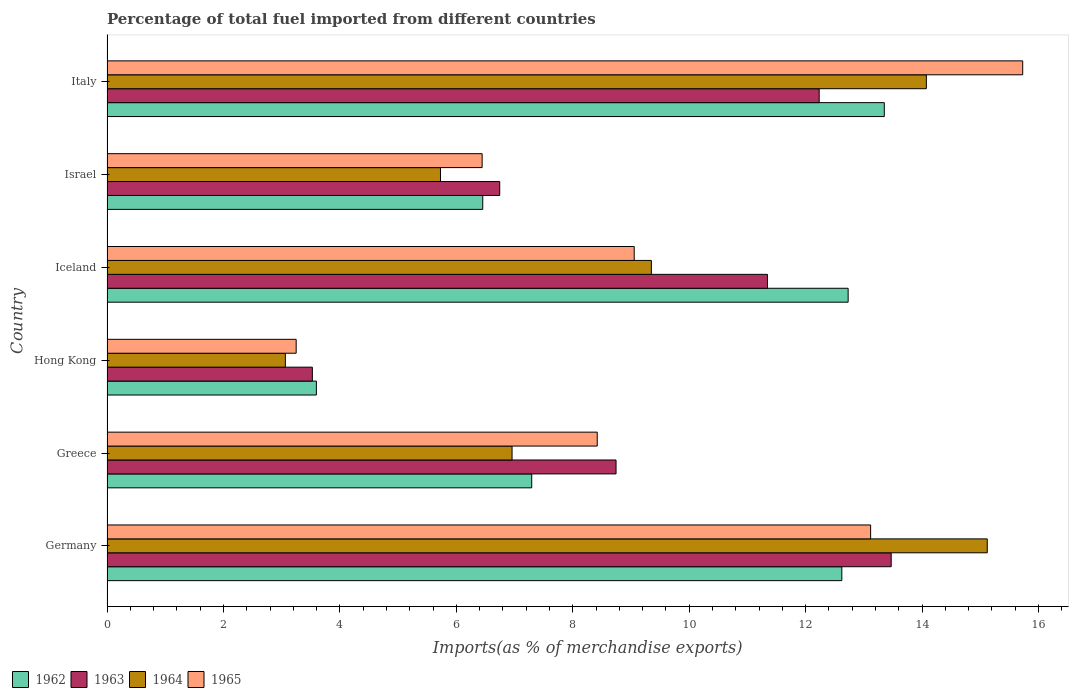How many groups of bars are there?
Make the answer very short. 6. Are the number of bars per tick equal to the number of legend labels?
Offer a terse response. Yes. Are the number of bars on each tick of the Y-axis equal?
Provide a succinct answer. Yes. What is the label of the 5th group of bars from the top?
Your answer should be very brief. Greece. In how many cases, is the number of bars for a given country not equal to the number of legend labels?
Your answer should be very brief. 0. What is the percentage of imports to different countries in 1965 in Iceland?
Your answer should be compact. 9.06. Across all countries, what is the maximum percentage of imports to different countries in 1964?
Your answer should be very brief. 15.12. Across all countries, what is the minimum percentage of imports to different countries in 1963?
Offer a terse response. 3.53. In which country was the percentage of imports to different countries in 1962 minimum?
Keep it short and to the point. Hong Kong. What is the total percentage of imports to different countries in 1962 in the graph?
Keep it short and to the point. 56.05. What is the difference between the percentage of imports to different countries in 1965 in Hong Kong and that in Israel?
Your response must be concise. -3.19. What is the difference between the percentage of imports to different countries in 1963 in Iceland and the percentage of imports to different countries in 1962 in Israel?
Keep it short and to the point. 4.89. What is the average percentage of imports to different countries in 1962 per country?
Offer a very short reply. 9.34. What is the difference between the percentage of imports to different countries in 1964 and percentage of imports to different countries in 1963 in Israel?
Provide a short and direct response. -1.02. In how many countries, is the percentage of imports to different countries in 1963 greater than 16 %?
Provide a short and direct response. 0. What is the ratio of the percentage of imports to different countries in 1964 in Germany to that in Israel?
Make the answer very short. 2.64. What is the difference between the highest and the second highest percentage of imports to different countries in 1962?
Provide a short and direct response. 0.62. What is the difference between the highest and the lowest percentage of imports to different countries in 1963?
Offer a very short reply. 9.94. In how many countries, is the percentage of imports to different countries in 1962 greater than the average percentage of imports to different countries in 1962 taken over all countries?
Ensure brevity in your answer.  3. Is the sum of the percentage of imports to different countries in 1965 in Iceland and Italy greater than the maximum percentage of imports to different countries in 1962 across all countries?
Offer a terse response. Yes. What does the 2nd bar from the top in Greece represents?
Your response must be concise. 1964. What does the 1st bar from the bottom in Israel represents?
Provide a succinct answer. 1962. Is it the case that in every country, the sum of the percentage of imports to different countries in 1963 and percentage of imports to different countries in 1962 is greater than the percentage of imports to different countries in 1965?
Keep it short and to the point. Yes. Are all the bars in the graph horizontal?
Your answer should be very brief. Yes. How many countries are there in the graph?
Provide a short and direct response. 6. Are the values on the major ticks of X-axis written in scientific E-notation?
Your answer should be very brief. No. Does the graph contain any zero values?
Offer a terse response. No. Does the graph contain grids?
Your answer should be compact. No. How are the legend labels stacked?
Offer a terse response. Horizontal. What is the title of the graph?
Your answer should be compact. Percentage of total fuel imported from different countries. Does "2011" appear as one of the legend labels in the graph?
Offer a terse response. No. What is the label or title of the X-axis?
Offer a very short reply. Imports(as % of merchandise exports). What is the label or title of the Y-axis?
Provide a short and direct response. Country. What is the Imports(as % of merchandise exports) in 1962 in Germany?
Provide a short and direct response. 12.62. What is the Imports(as % of merchandise exports) in 1963 in Germany?
Offer a terse response. 13.47. What is the Imports(as % of merchandise exports) of 1964 in Germany?
Make the answer very short. 15.12. What is the Imports(as % of merchandise exports) of 1965 in Germany?
Provide a succinct answer. 13.12. What is the Imports(as % of merchandise exports) of 1962 in Greece?
Offer a terse response. 7.3. What is the Imports(as % of merchandise exports) of 1963 in Greece?
Your answer should be compact. 8.74. What is the Imports(as % of merchandise exports) of 1964 in Greece?
Keep it short and to the point. 6.96. What is the Imports(as % of merchandise exports) of 1965 in Greece?
Your answer should be compact. 8.42. What is the Imports(as % of merchandise exports) of 1962 in Hong Kong?
Offer a terse response. 3.6. What is the Imports(as % of merchandise exports) of 1963 in Hong Kong?
Provide a short and direct response. 3.53. What is the Imports(as % of merchandise exports) of 1964 in Hong Kong?
Offer a very short reply. 3.06. What is the Imports(as % of merchandise exports) of 1965 in Hong Kong?
Provide a short and direct response. 3.25. What is the Imports(as % of merchandise exports) of 1962 in Iceland?
Provide a short and direct response. 12.73. What is the Imports(as % of merchandise exports) of 1963 in Iceland?
Your answer should be very brief. 11.35. What is the Imports(as % of merchandise exports) of 1964 in Iceland?
Offer a very short reply. 9.35. What is the Imports(as % of merchandise exports) of 1965 in Iceland?
Provide a short and direct response. 9.06. What is the Imports(as % of merchandise exports) in 1962 in Israel?
Provide a short and direct response. 6.45. What is the Imports(as % of merchandise exports) in 1963 in Israel?
Your answer should be very brief. 6.75. What is the Imports(as % of merchandise exports) of 1964 in Israel?
Your answer should be very brief. 5.73. What is the Imports(as % of merchandise exports) in 1965 in Israel?
Offer a very short reply. 6.44. What is the Imports(as % of merchandise exports) in 1962 in Italy?
Give a very brief answer. 13.35. What is the Imports(as % of merchandise exports) of 1963 in Italy?
Your answer should be compact. 12.23. What is the Imports(as % of merchandise exports) of 1964 in Italy?
Keep it short and to the point. 14.07. What is the Imports(as % of merchandise exports) in 1965 in Italy?
Offer a terse response. 15.73. Across all countries, what is the maximum Imports(as % of merchandise exports) in 1962?
Your response must be concise. 13.35. Across all countries, what is the maximum Imports(as % of merchandise exports) of 1963?
Ensure brevity in your answer.  13.47. Across all countries, what is the maximum Imports(as % of merchandise exports) in 1964?
Ensure brevity in your answer.  15.12. Across all countries, what is the maximum Imports(as % of merchandise exports) of 1965?
Your answer should be compact. 15.73. Across all countries, what is the minimum Imports(as % of merchandise exports) in 1962?
Ensure brevity in your answer.  3.6. Across all countries, what is the minimum Imports(as % of merchandise exports) of 1963?
Ensure brevity in your answer.  3.53. Across all countries, what is the minimum Imports(as % of merchandise exports) in 1964?
Keep it short and to the point. 3.06. Across all countries, what is the minimum Imports(as % of merchandise exports) in 1965?
Ensure brevity in your answer.  3.25. What is the total Imports(as % of merchandise exports) in 1962 in the graph?
Offer a very short reply. 56.05. What is the total Imports(as % of merchandise exports) in 1963 in the graph?
Give a very brief answer. 56.07. What is the total Imports(as % of merchandise exports) in 1964 in the graph?
Provide a short and direct response. 54.3. What is the total Imports(as % of merchandise exports) of 1965 in the graph?
Ensure brevity in your answer.  56.02. What is the difference between the Imports(as % of merchandise exports) of 1962 in Germany and that in Greece?
Provide a succinct answer. 5.33. What is the difference between the Imports(as % of merchandise exports) in 1963 in Germany and that in Greece?
Offer a very short reply. 4.73. What is the difference between the Imports(as % of merchandise exports) of 1964 in Germany and that in Greece?
Your response must be concise. 8.16. What is the difference between the Imports(as % of merchandise exports) in 1965 in Germany and that in Greece?
Keep it short and to the point. 4.7. What is the difference between the Imports(as % of merchandise exports) of 1962 in Germany and that in Hong Kong?
Offer a terse response. 9.03. What is the difference between the Imports(as % of merchandise exports) of 1963 in Germany and that in Hong Kong?
Provide a succinct answer. 9.94. What is the difference between the Imports(as % of merchandise exports) of 1964 in Germany and that in Hong Kong?
Offer a terse response. 12.06. What is the difference between the Imports(as % of merchandise exports) of 1965 in Germany and that in Hong Kong?
Provide a succinct answer. 9.87. What is the difference between the Imports(as % of merchandise exports) in 1962 in Germany and that in Iceland?
Keep it short and to the point. -0.11. What is the difference between the Imports(as % of merchandise exports) in 1963 in Germany and that in Iceland?
Give a very brief answer. 2.13. What is the difference between the Imports(as % of merchandise exports) of 1964 in Germany and that in Iceland?
Keep it short and to the point. 5.77. What is the difference between the Imports(as % of merchandise exports) of 1965 in Germany and that in Iceland?
Make the answer very short. 4.06. What is the difference between the Imports(as % of merchandise exports) in 1962 in Germany and that in Israel?
Your response must be concise. 6.17. What is the difference between the Imports(as % of merchandise exports) in 1963 in Germany and that in Israel?
Offer a very short reply. 6.72. What is the difference between the Imports(as % of merchandise exports) in 1964 in Germany and that in Israel?
Provide a short and direct response. 9.39. What is the difference between the Imports(as % of merchandise exports) in 1965 in Germany and that in Israel?
Your response must be concise. 6.67. What is the difference between the Imports(as % of merchandise exports) in 1962 in Germany and that in Italy?
Make the answer very short. -0.73. What is the difference between the Imports(as % of merchandise exports) of 1963 in Germany and that in Italy?
Ensure brevity in your answer.  1.24. What is the difference between the Imports(as % of merchandise exports) of 1964 in Germany and that in Italy?
Your answer should be very brief. 1.05. What is the difference between the Imports(as % of merchandise exports) of 1965 in Germany and that in Italy?
Ensure brevity in your answer.  -2.61. What is the difference between the Imports(as % of merchandise exports) in 1962 in Greece and that in Hong Kong?
Provide a succinct answer. 3.7. What is the difference between the Imports(as % of merchandise exports) of 1963 in Greece and that in Hong Kong?
Your answer should be compact. 5.22. What is the difference between the Imports(as % of merchandise exports) in 1964 in Greece and that in Hong Kong?
Give a very brief answer. 3.89. What is the difference between the Imports(as % of merchandise exports) in 1965 in Greece and that in Hong Kong?
Give a very brief answer. 5.17. What is the difference between the Imports(as % of merchandise exports) of 1962 in Greece and that in Iceland?
Give a very brief answer. -5.44. What is the difference between the Imports(as % of merchandise exports) of 1963 in Greece and that in Iceland?
Offer a very short reply. -2.6. What is the difference between the Imports(as % of merchandise exports) in 1964 in Greece and that in Iceland?
Your answer should be compact. -2.39. What is the difference between the Imports(as % of merchandise exports) in 1965 in Greece and that in Iceland?
Make the answer very short. -0.64. What is the difference between the Imports(as % of merchandise exports) in 1962 in Greece and that in Israel?
Provide a succinct answer. 0.84. What is the difference between the Imports(as % of merchandise exports) of 1963 in Greece and that in Israel?
Your answer should be very brief. 2. What is the difference between the Imports(as % of merchandise exports) in 1964 in Greece and that in Israel?
Your answer should be very brief. 1.23. What is the difference between the Imports(as % of merchandise exports) of 1965 in Greece and that in Israel?
Your answer should be compact. 1.98. What is the difference between the Imports(as % of merchandise exports) in 1962 in Greece and that in Italy?
Ensure brevity in your answer.  -6.06. What is the difference between the Imports(as % of merchandise exports) of 1963 in Greece and that in Italy?
Ensure brevity in your answer.  -3.49. What is the difference between the Imports(as % of merchandise exports) of 1964 in Greece and that in Italy?
Offer a terse response. -7.12. What is the difference between the Imports(as % of merchandise exports) of 1965 in Greece and that in Italy?
Your answer should be compact. -7.31. What is the difference between the Imports(as % of merchandise exports) in 1962 in Hong Kong and that in Iceland?
Give a very brief answer. -9.13. What is the difference between the Imports(as % of merchandise exports) of 1963 in Hong Kong and that in Iceland?
Ensure brevity in your answer.  -7.82. What is the difference between the Imports(as % of merchandise exports) of 1964 in Hong Kong and that in Iceland?
Your answer should be compact. -6.29. What is the difference between the Imports(as % of merchandise exports) in 1965 in Hong Kong and that in Iceland?
Your answer should be compact. -5.81. What is the difference between the Imports(as % of merchandise exports) of 1962 in Hong Kong and that in Israel?
Offer a very short reply. -2.86. What is the difference between the Imports(as % of merchandise exports) of 1963 in Hong Kong and that in Israel?
Make the answer very short. -3.22. What is the difference between the Imports(as % of merchandise exports) in 1964 in Hong Kong and that in Israel?
Your answer should be very brief. -2.66. What is the difference between the Imports(as % of merchandise exports) in 1965 in Hong Kong and that in Israel?
Offer a terse response. -3.19. What is the difference between the Imports(as % of merchandise exports) of 1962 in Hong Kong and that in Italy?
Your response must be concise. -9.76. What is the difference between the Imports(as % of merchandise exports) of 1963 in Hong Kong and that in Italy?
Your answer should be very brief. -8.71. What is the difference between the Imports(as % of merchandise exports) in 1964 in Hong Kong and that in Italy?
Keep it short and to the point. -11.01. What is the difference between the Imports(as % of merchandise exports) of 1965 in Hong Kong and that in Italy?
Keep it short and to the point. -12.48. What is the difference between the Imports(as % of merchandise exports) of 1962 in Iceland and that in Israel?
Offer a terse response. 6.28. What is the difference between the Imports(as % of merchandise exports) of 1963 in Iceland and that in Israel?
Your answer should be compact. 4.6. What is the difference between the Imports(as % of merchandise exports) of 1964 in Iceland and that in Israel?
Your answer should be very brief. 3.62. What is the difference between the Imports(as % of merchandise exports) in 1965 in Iceland and that in Israel?
Your answer should be very brief. 2.61. What is the difference between the Imports(as % of merchandise exports) in 1962 in Iceland and that in Italy?
Keep it short and to the point. -0.62. What is the difference between the Imports(as % of merchandise exports) of 1963 in Iceland and that in Italy?
Make the answer very short. -0.89. What is the difference between the Imports(as % of merchandise exports) in 1964 in Iceland and that in Italy?
Offer a very short reply. -4.72. What is the difference between the Imports(as % of merchandise exports) of 1965 in Iceland and that in Italy?
Provide a short and direct response. -6.67. What is the difference between the Imports(as % of merchandise exports) of 1962 in Israel and that in Italy?
Provide a succinct answer. -6.9. What is the difference between the Imports(as % of merchandise exports) of 1963 in Israel and that in Italy?
Offer a very short reply. -5.49. What is the difference between the Imports(as % of merchandise exports) of 1964 in Israel and that in Italy?
Make the answer very short. -8.35. What is the difference between the Imports(as % of merchandise exports) in 1965 in Israel and that in Italy?
Make the answer very short. -9.29. What is the difference between the Imports(as % of merchandise exports) of 1962 in Germany and the Imports(as % of merchandise exports) of 1963 in Greece?
Your response must be concise. 3.88. What is the difference between the Imports(as % of merchandise exports) of 1962 in Germany and the Imports(as % of merchandise exports) of 1964 in Greece?
Your answer should be very brief. 5.66. What is the difference between the Imports(as % of merchandise exports) of 1962 in Germany and the Imports(as % of merchandise exports) of 1965 in Greece?
Provide a short and direct response. 4.2. What is the difference between the Imports(as % of merchandise exports) in 1963 in Germany and the Imports(as % of merchandise exports) in 1964 in Greece?
Provide a succinct answer. 6.51. What is the difference between the Imports(as % of merchandise exports) in 1963 in Germany and the Imports(as % of merchandise exports) in 1965 in Greece?
Keep it short and to the point. 5.05. What is the difference between the Imports(as % of merchandise exports) in 1964 in Germany and the Imports(as % of merchandise exports) in 1965 in Greece?
Your answer should be very brief. 6.7. What is the difference between the Imports(as % of merchandise exports) of 1962 in Germany and the Imports(as % of merchandise exports) of 1963 in Hong Kong?
Keep it short and to the point. 9.1. What is the difference between the Imports(as % of merchandise exports) of 1962 in Germany and the Imports(as % of merchandise exports) of 1964 in Hong Kong?
Offer a terse response. 9.56. What is the difference between the Imports(as % of merchandise exports) of 1962 in Germany and the Imports(as % of merchandise exports) of 1965 in Hong Kong?
Your answer should be compact. 9.37. What is the difference between the Imports(as % of merchandise exports) in 1963 in Germany and the Imports(as % of merchandise exports) in 1964 in Hong Kong?
Make the answer very short. 10.41. What is the difference between the Imports(as % of merchandise exports) in 1963 in Germany and the Imports(as % of merchandise exports) in 1965 in Hong Kong?
Ensure brevity in your answer.  10.22. What is the difference between the Imports(as % of merchandise exports) of 1964 in Germany and the Imports(as % of merchandise exports) of 1965 in Hong Kong?
Provide a short and direct response. 11.87. What is the difference between the Imports(as % of merchandise exports) in 1962 in Germany and the Imports(as % of merchandise exports) in 1963 in Iceland?
Offer a very short reply. 1.28. What is the difference between the Imports(as % of merchandise exports) of 1962 in Germany and the Imports(as % of merchandise exports) of 1964 in Iceland?
Your response must be concise. 3.27. What is the difference between the Imports(as % of merchandise exports) of 1962 in Germany and the Imports(as % of merchandise exports) of 1965 in Iceland?
Give a very brief answer. 3.57. What is the difference between the Imports(as % of merchandise exports) of 1963 in Germany and the Imports(as % of merchandise exports) of 1964 in Iceland?
Offer a terse response. 4.12. What is the difference between the Imports(as % of merchandise exports) of 1963 in Germany and the Imports(as % of merchandise exports) of 1965 in Iceland?
Offer a very short reply. 4.41. What is the difference between the Imports(as % of merchandise exports) of 1964 in Germany and the Imports(as % of merchandise exports) of 1965 in Iceland?
Ensure brevity in your answer.  6.06. What is the difference between the Imports(as % of merchandise exports) of 1962 in Germany and the Imports(as % of merchandise exports) of 1963 in Israel?
Make the answer very short. 5.88. What is the difference between the Imports(as % of merchandise exports) of 1962 in Germany and the Imports(as % of merchandise exports) of 1964 in Israel?
Ensure brevity in your answer.  6.89. What is the difference between the Imports(as % of merchandise exports) of 1962 in Germany and the Imports(as % of merchandise exports) of 1965 in Israel?
Keep it short and to the point. 6.18. What is the difference between the Imports(as % of merchandise exports) of 1963 in Germany and the Imports(as % of merchandise exports) of 1964 in Israel?
Keep it short and to the point. 7.74. What is the difference between the Imports(as % of merchandise exports) in 1963 in Germany and the Imports(as % of merchandise exports) in 1965 in Israel?
Make the answer very short. 7.03. What is the difference between the Imports(as % of merchandise exports) of 1964 in Germany and the Imports(as % of merchandise exports) of 1965 in Israel?
Offer a very short reply. 8.68. What is the difference between the Imports(as % of merchandise exports) of 1962 in Germany and the Imports(as % of merchandise exports) of 1963 in Italy?
Give a very brief answer. 0.39. What is the difference between the Imports(as % of merchandise exports) in 1962 in Germany and the Imports(as % of merchandise exports) in 1964 in Italy?
Provide a succinct answer. -1.45. What is the difference between the Imports(as % of merchandise exports) of 1962 in Germany and the Imports(as % of merchandise exports) of 1965 in Italy?
Your response must be concise. -3.11. What is the difference between the Imports(as % of merchandise exports) in 1963 in Germany and the Imports(as % of merchandise exports) in 1964 in Italy?
Offer a very short reply. -0.6. What is the difference between the Imports(as % of merchandise exports) in 1963 in Germany and the Imports(as % of merchandise exports) in 1965 in Italy?
Offer a terse response. -2.26. What is the difference between the Imports(as % of merchandise exports) of 1964 in Germany and the Imports(as % of merchandise exports) of 1965 in Italy?
Your answer should be compact. -0.61. What is the difference between the Imports(as % of merchandise exports) in 1962 in Greece and the Imports(as % of merchandise exports) in 1963 in Hong Kong?
Your answer should be compact. 3.77. What is the difference between the Imports(as % of merchandise exports) in 1962 in Greece and the Imports(as % of merchandise exports) in 1964 in Hong Kong?
Your response must be concise. 4.23. What is the difference between the Imports(as % of merchandise exports) in 1962 in Greece and the Imports(as % of merchandise exports) in 1965 in Hong Kong?
Provide a succinct answer. 4.05. What is the difference between the Imports(as % of merchandise exports) in 1963 in Greece and the Imports(as % of merchandise exports) in 1964 in Hong Kong?
Your response must be concise. 5.68. What is the difference between the Imports(as % of merchandise exports) of 1963 in Greece and the Imports(as % of merchandise exports) of 1965 in Hong Kong?
Provide a short and direct response. 5.49. What is the difference between the Imports(as % of merchandise exports) in 1964 in Greece and the Imports(as % of merchandise exports) in 1965 in Hong Kong?
Your response must be concise. 3.71. What is the difference between the Imports(as % of merchandise exports) in 1962 in Greece and the Imports(as % of merchandise exports) in 1963 in Iceland?
Offer a very short reply. -4.05. What is the difference between the Imports(as % of merchandise exports) in 1962 in Greece and the Imports(as % of merchandise exports) in 1964 in Iceland?
Offer a very short reply. -2.06. What is the difference between the Imports(as % of merchandise exports) of 1962 in Greece and the Imports(as % of merchandise exports) of 1965 in Iceland?
Provide a succinct answer. -1.76. What is the difference between the Imports(as % of merchandise exports) of 1963 in Greece and the Imports(as % of merchandise exports) of 1964 in Iceland?
Offer a very short reply. -0.61. What is the difference between the Imports(as % of merchandise exports) in 1963 in Greece and the Imports(as % of merchandise exports) in 1965 in Iceland?
Offer a very short reply. -0.31. What is the difference between the Imports(as % of merchandise exports) in 1964 in Greece and the Imports(as % of merchandise exports) in 1965 in Iceland?
Offer a very short reply. -2.1. What is the difference between the Imports(as % of merchandise exports) in 1962 in Greece and the Imports(as % of merchandise exports) in 1963 in Israel?
Your answer should be compact. 0.55. What is the difference between the Imports(as % of merchandise exports) of 1962 in Greece and the Imports(as % of merchandise exports) of 1964 in Israel?
Ensure brevity in your answer.  1.57. What is the difference between the Imports(as % of merchandise exports) of 1962 in Greece and the Imports(as % of merchandise exports) of 1965 in Israel?
Provide a short and direct response. 0.85. What is the difference between the Imports(as % of merchandise exports) of 1963 in Greece and the Imports(as % of merchandise exports) of 1964 in Israel?
Your response must be concise. 3.02. What is the difference between the Imports(as % of merchandise exports) of 1963 in Greece and the Imports(as % of merchandise exports) of 1965 in Israel?
Keep it short and to the point. 2.3. What is the difference between the Imports(as % of merchandise exports) in 1964 in Greece and the Imports(as % of merchandise exports) in 1965 in Israel?
Keep it short and to the point. 0.51. What is the difference between the Imports(as % of merchandise exports) in 1962 in Greece and the Imports(as % of merchandise exports) in 1963 in Italy?
Your response must be concise. -4.94. What is the difference between the Imports(as % of merchandise exports) of 1962 in Greece and the Imports(as % of merchandise exports) of 1964 in Italy?
Offer a very short reply. -6.78. What is the difference between the Imports(as % of merchandise exports) in 1962 in Greece and the Imports(as % of merchandise exports) in 1965 in Italy?
Your answer should be very brief. -8.43. What is the difference between the Imports(as % of merchandise exports) in 1963 in Greece and the Imports(as % of merchandise exports) in 1964 in Italy?
Provide a short and direct response. -5.33. What is the difference between the Imports(as % of merchandise exports) in 1963 in Greece and the Imports(as % of merchandise exports) in 1965 in Italy?
Give a very brief answer. -6.99. What is the difference between the Imports(as % of merchandise exports) in 1964 in Greece and the Imports(as % of merchandise exports) in 1965 in Italy?
Keep it short and to the point. -8.77. What is the difference between the Imports(as % of merchandise exports) of 1962 in Hong Kong and the Imports(as % of merchandise exports) of 1963 in Iceland?
Keep it short and to the point. -7.75. What is the difference between the Imports(as % of merchandise exports) of 1962 in Hong Kong and the Imports(as % of merchandise exports) of 1964 in Iceland?
Your response must be concise. -5.75. What is the difference between the Imports(as % of merchandise exports) in 1962 in Hong Kong and the Imports(as % of merchandise exports) in 1965 in Iceland?
Keep it short and to the point. -5.46. What is the difference between the Imports(as % of merchandise exports) of 1963 in Hong Kong and the Imports(as % of merchandise exports) of 1964 in Iceland?
Provide a short and direct response. -5.82. What is the difference between the Imports(as % of merchandise exports) in 1963 in Hong Kong and the Imports(as % of merchandise exports) in 1965 in Iceland?
Ensure brevity in your answer.  -5.53. What is the difference between the Imports(as % of merchandise exports) in 1964 in Hong Kong and the Imports(as % of merchandise exports) in 1965 in Iceland?
Ensure brevity in your answer.  -5.99. What is the difference between the Imports(as % of merchandise exports) in 1962 in Hong Kong and the Imports(as % of merchandise exports) in 1963 in Israel?
Offer a very short reply. -3.15. What is the difference between the Imports(as % of merchandise exports) in 1962 in Hong Kong and the Imports(as % of merchandise exports) in 1964 in Israel?
Make the answer very short. -2.13. What is the difference between the Imports(as % of merchandise exports) in 1962 in Hong Kong and the Imports(as % of merchandise exports) in 1965 in Israel?
Offer a very short reply. -2.85. What is the difference between the Imports(as % of merchandise exports) in 1963 in Hong Kong and the Imports(as % of merchandise exports) in 1964 in Israel?
Provide a succinct answer. -2.2. What is the difference between the Imports(as % of merchandise exports) of 1963 in Hong Kong and the Imports(as % of merchandise exports) of 1965 in Israel?
Your answer should be compact. -2.92. What is the difference between the Imports(as % of merchandise exports) in 1964 in Hong Kong and the Imports(as % of merchandise exports) in 1965 in Israel?
Your answer should be compact. -3.38. What is the difference between the Imports(as % of merchandise exports) of 1962 in Hong Kong and the Imports(as % of merchandise exports) of 1963 in Italy?
Offer a very short reply. -8.64. What is the difference between the Imports(as % of merchandise exports) in 1962 in Hong Kong and the Imports(as % of merchandise exports) in 1964 in Italy?
Provide a succinct answer. -10.48. What is the difference between the Imports(as % of merchandise exports) in 1962 in Hong Kong and the Imports(as % of merchandise exports) in 1965 in Italy?
Provide a short and direct response. -12.13. What is the difference between the Imports(as % of merchandise exports) of 1963 in Hong Kong and the Imports(as % of merchandise exports) of 1964 in Italy?
Give a very brief answer. -10.55. What is the difference between the Imports(as % of merchandise exports) of 1963 in Hong Kong and the Imports(as % of merchandise exports) of 1965 in Italy?
Make the answer very short. -12.2. What is the difference between the Imports(as % of merchandise exports) of 1964 in Hong Kong and the Imports(as % of merchandise exports) of 1965 in Italy?
Make the answer very short. -12.67. What is the difference between the Imports(as % of merchandise exports) of 1962 in Iceland and the Imports(as % of merchandise exports) of 1963 in Israel?
Give a very brief answer. 5.99. What is the difference between the Imports(as % of merchandise exports) in 1962 in Iceland and the Imports(as % of merchandise exports) in 1964 in Israel?
Your answer should be very brief. 7. What is the difference between the Imports(as % of merchandise exports) of 1962 in Iceland and the Imports(as % of merchandise exports) of 1965 in Israel?
Offer a terse response. 6.29. What is the difference between the Imports(as % of merchandise exports) of 1963 in Iceland and the Imports(as % of merchandise exports) of 1964 in Israel?
Your answer should be compact. 5.62. What is the difference between the Imports(as % of merchandise exports) of 1963 in Iceland and the Imports(as % of merchandise exports) of 1965 in Israel?
Offer a very short reply. 4.9. What is the difference between the Imports(as % of merchandise exports) of 1964 in Iceland and the Imports(as % of merchandise exports) of 1965 in Israel?
Offer a very short reply. 2.91. What is the difference between the Imports(as % of merchandise exports) in 1962 in Iceland and the Imports(as % of merchandise exports) in 1963 in Italy?
Your response must be concise. 0.5. What is the difference between the Imports(as % of merchandise exports) in 1962 in Iceland and the Imports(as % of merchandise exports) in 1964 in Italy?
Your answer should be very brief. -1.34. What is the difference between the Imports(as % of merchandise exports) of 1962 in Iceland and the Imports(as % of merchandise exports) of 1965 in Italy?
Your response must be concise. -3. What is the difference between the Imports(as % of merchandise exports) in 1963 in Iceland and the Imports(as % of merchandise exports) in 1964 in Italy?
Your answer should be very brief. -2.73. What is the difference between the Imports(as % of merchandise exports) of 1963 in Iceland and the Imports(as % of merchandise exports) of 1965 in Italy?
Give a very brief answer. -4.38. What is the difference between the Imports(as % of merchandise exports) of 1964 in Iceland and the Imports(as % of merchandise exports) of 1965 in Italy?
Give a very brief answer. -6.38. What is the difference between the Imports(as % of merchandise exports) of 1962 in Israel and the Imports(as % of merchandise exports) of 1963 in Italy?
Ensure brevity in your answer.  -5.78. What is the difference between the Imports(as % of merchandise exports) of 1962 in Israel and the Imports(as % of merchandise exports) of 1964 in Italy?
Ensure brevity in your answer.  -7.62. What is the difference between the Imports(as % of merchandise exports) of 1962 in Israel and the Imports(as % of merchandise exports) of 1965 in Italy?
Offer a terse response. -9.28. What is the difference between the Imports(as % of merchandise exports) of 1963 in Israel and the Imports(as % of merchandise exports) of 1964 in Italy?
Ensure brevity in your answer.  -7.33. What is the difference between the Imports(as % of merchandise exports) of 1963 in Israel and the Imports(as % of merchandise exports) of 1965 in Italy?
Your answer should be very brief. -8.98. What is the difference between the Imports(as % of merchandise exports) in 1964 in Israel and the Imports(as % of merchandise exports) in 1965 in Italy?
Provide a succinct answer. -10. What is the average Imports(as % of merchandise exports) of 1962 per country?
Your response must be concise. 9.34. What is the average Imports(as % of merchandise exports) in 1963 per country?
Provide a succinct answer. 9.34. What is the average Imports(as % of merchandise exports) in 1964 per country?
Ensure brevity in your answer.  9.05. What is the average Imports(as % of merchandise exports) in 1965 per country?
Your answer should be very brief. 9.34. What is the difference between the Imports(as % of merchandise exports) in 1962 and Imports(as % of merchandise exports) in 1963 in Germany?
Provide a short and direct response. -0.85. What is the difference between the Imports(as % of merchandise exports) of 1962 and Imports(as % of merchandise exports) of 1964 in Germany?
Offer a terse response. -2.5. What is the difference between the Imports(as % of merchandise exports) of 1962 and Imports(as % of merchandise exports) of 1965 in Germany?
Keep it short and to the point. -0.49. What is the difference between the Imports(as % of merchandise exports) of 1963 and Imports(as % of merchandise exports) of 1964 in Germany?
Provide a succinct answer. -1.65. What is the difference between the Imports(as % of merchandise exports) of 1963 and Imports(as % of merchandise exports) of 1965 in Germany?
Give a very brief answer. 0.35. What is the difference between the Imports(as % of merchandise exports) in 1964 and Imports(as % of merchandise exports) in 1965 in Germany?
Provide a succinct answer. 2. What is the difference between the Imports(as % of merchandise exports) in 1962 and Imports(as % of merchandise exports) in 1963 in Greece?
Provide a succinct answer. -1.45. What is the difference between the Imports(as % of merchandise exports) of 1962 and Imports(as % of merchandise exports) of 1964 in Greece?
Give a very brief answer. 0.34. What is the difference between the Imports(as % of merchandise exports) in 1962 and Imports(as % of merchandise exports) in 1965 in Greece?
Make the answer very short. -1.13. What is the difference between the Imports(as % of merchandise exports) in 1963 and Imports(as % of merchandise exports) in 1964 in Greece?
Keep it short and to the point. 1.79. What is the difference between the Imports(as % of merchandise exports) of 1963 and Imports(as % of merchandise exports) of 1965 in Greece?
Offer a terse response. 0.32. What is the difference between the Imports(as % of merchandise exports) in 1964 and Imports(as % of merchandise exports) in 1965 in Greece?
Your response must be concise. -1.46. What is the difference between the Imports(as % of merchandise exports) of 1962 and Imports(as % of merchandise exports) of 1963 in Hong Kong?
Offer a very short reply. 0.07. What is the difference between the Imports(as % of merchandise exports) in 1962 and Imports(as % of merchandise exports) in 1964 in Hong Kong?
Offer a very short reply. 0.53. What is the difference between the Imports(as % of merchandise exports) of 1962 and Imports(as % of merchandise exports) of 1965 in Hong Kong?
Keep it short and to the point. 0.35. What is the difference between the Imports(as % of merchandise exports) of 1963 and Imports(as % of merchandise exports) of 1964 in Hong Kong?
Provide a short and direct response. 0.46. What is the difference between the Imports(as % of merchandise exports) in 1963 and Imports(as % of merchandise exports) in 1965 in Hong Kong?
Make the answer very short. 0.28. What is the difference between the Imports(as % of merchandise exports) of 1964 and Imports(as % of merchandise exports) of 1965 in Hong Kong?
Provide a succinct answer. -0.19. What is the difference between the Imports(as % of merchandise exports) in 1962 and Imports(as % of merchandise exports) in 1963 in Iceland?
Keep it short and to the point. 1.39. What is the difference between the Imports(as % of merchandise exports) in 1962 and Imports(as % of merchandise exports) in 1964 in Iceland?
Provide a short and direct response. 3.38. What is the difference between the Imports(as % of merchandise exports) in 1962 and Imports(as % of merchandise exports) in 1965 in Iceland?
Your answer should be compact. 3.67. What is the difference between the Imports(as % of merchandise exports) of 1963 and Imports(as % of merchandise exports) of 1964 in Iceland?
Provide a succinct answer. 1.99. What is the difference between the Imports(as % of merchandise exports) of 1963 and Imports(as % of merchandise exports) of 1965 in Iceland?
Offer a very short reply. 2.29. What is the difference between the Imports(as % of merchandise exports) in 1964 and Imports(as % of merchandise exports) in 1965 in Iceland?
Ensure brevity in your answer.  0.29. What is the difference between the Imports(as % of merchandise exports) of 1962 and Imports(as % of merchandise exports) of 1963 in Israel?
Provide a short and direct response. -0.29. What is the difference between the Imports(as % of merchandise exports) in 1962 and Imports(as % of merchandise exports) in 1964 in Israel?
Your response must be concise. 0.73. What is the difference between the Imports(as % of merchandise exports) in 1962 and Imports(as % of merchandise exports) in 1965 in Israel?
Give a very brief answer. 0.01. What is the difference between the Imports(as % of merchandise exports) in 1963 and Imports(as % of merchandise exports) in 1964 in Israel?
Make the answer very short. 1.02. What is the difference between the Imports(as % of merchandise exports) in 1963 and Imports(as % of merchandise exports) in 1965 in Israel?
Your response must be concise. 0.3. What is the difference between the Imports(as % of merchandise exports) of 1964 and Imports(as % of merchandise exports) of 1965 in Israel?
Give a very brief answer. -0.72. What is the difference between the Imports(as % of merchandise exports) in 1962 and Imports(as % of merchandise exports) in 1963 in Italy?
Your answer should be very brief. 1.12. What is the difference between the Imports(as % of merchandise exports) of 1962 and Imports(as % of merchandise exports) of 1964 in Italy?
Ensure brevity in your answer.  -0.72. What is the difference between the Imports(as % of merchandise exports) in 1962 and Imports(as % of merchandise exports) in 1965 in Italy?
Offer a very short reply. -2.38. What is the difference between the Imports(as % of merchandise exports) in 1963 and Imports(as % of merchandise exports) in 1964 in Italy?
Offer a terse response. -1.84. What is the difference between the Imports(as % of merchandise exports) in 1963 and Imports(as % of merchandise exports) in 1965 in Italy?
Make the answer very short. -3.5. What is the difference between the Imports(as % of merchandise exports) in 1964 and Imports(as % of merchandise exports) in 1965 in Italy?
Provide a short and direct response. -1.65. What is the ratio of the Imports(as % of merchandise exports) of 1962 in Germany to that in Greece?
Offer a very short reply. 1.73. What is the ratio of the Imports(as % of merchandise exports) of 1963 in Germany to that in Greece?
Your answer should be compact. 1.54. What is the ratio of the Imports(as % of merchandise exports) in 1964 in Germany to that in Greece?
Keep it short and to the point. 2.17. What is the ratio of the Imports(as % of merchandise exports) of 1965 in Germany to that in Greece?
Keep it short and to the point. 1.56. What is the ratio of the Imports(as % of merchandise exports) of 1962 in Germany to that in Hong Kong?
Your answer should be very brief. 3.51. What is the ratio of the Imports(as % of merchandise exports) of 1963 in Germany to that in Hong Kong?
Offer a terse response. 3.82. What is the ratio of the Imports(as % of merchandise exports) in 1964 in Germany to that in Hong Kong?
Offer a very short reply. 4.94. What is the ratio of the Imports(as % of merchandise exports) of 1965 in Germany to that in Hong Kong?
Offer a terse response. 4.04. What is the ratio of the Imports(as % of merchandise exports) in 1963 in Germany to that in Iceland?
Give a very brief answer. 1.19. What is the ratio of the Imports(as % of merchandise exports) of 1964 in Germany to that in Iceland?
Give a very brief answer. 1.62. What is the ratio of the Imports(as % of merchandise exports) in 1965 in Germany to that in Iceland?
Your answer should be compact. 1.45. What is the ratio of the Imports(as % of merchandise exports) in 1962 in Germany to that in Israel?
Provide a short and direct response. 1.96. What is the ratio of the Imports(as % of merchandise exports) in 1963 in Germany to that in Israel?
Give a very brief answer. 2. What is the ratio of the Imports(as % of merchandise exports) of 1964 in Germany to that in Israel?
Provide a short and direct response. 2.64. What is the ratio of the Imports(as % of merchandise exports) in 1965 in Germany to that in Israel?
Your answer should be compact. 2.04. What is the ratio of the Imports(as % of merchandise exports) in 1962 in Germany to that in Italy?
Give a very brief answer. 0.95. What is the ratio of the Imports(as % of merchandise exports) in 1963 in Germany to that in Italy?
Keep it short and to the point. 1.1. What is the ratio of the Imports(as % of merchandise exports) of 1964 in Germany to that in Italy?
Offer a very short reply. 1.07. What is the ratio of the Imports(as % of merchandise exports) of 1965 in Germany to that in Italy?
Provide a succinct answer. 0.83. What is the ratio of the Imports(as % of merchandise exports) of 1962 in Greece to that in Hong Kong?
Your response must be concise. 2.03. What is the ratio of the Imports(as % of merchandise exports) of 1963 in Greece to that in Hong Kong?
Make the answer very short. 2.48. What is the ratio of the Imports(as % of merchandise exports) in 1964 in Greece to that in Hong Kong?
Provide a succinct answer. 2.27. What is the ratio of the Imports(as % of merchandise exports) in 1965 in Greece to that in Hong Kong?
Offer a very short reply. 2.59. What is the ratio of the Imports(as % of merchandise exports) of 1962 in Greece to that in Iceland?
Provide a short and direct response. 0.57. What is the ratio of the Imports(as % of merchandise exports) in 1963 in Greece to that in Iceland?
Keep it short and to the point. 0.77. What is the ratio of the Imports(as % of merchandise exports) in 1964 in Greece to that in Iceland?
Provide a succinct answer. 0.74. What is the ratio of the Imports(as % of merchandise exports) in 1965 in Greece to that in Iceland?
Offer a very short reply. 0.93. What is the ratio of the Imports(as % of merchandise exports) in 1962 in Greece to that in Israel?
Offer a terse response. 1.13. What is the ratio of the Imports(as % of merchandise exports) of 1963 in Greece to that in Israel?
Ensure brevity in your answer.  1.3. What is the ratio of the Imports(as % of merchandise exports) of 1964 in Greece to that in Israel?
Your answer should be very brief. 1.21. What is the ratio of the Imports(as % of merchandise exports) in 1965 in Greece to that in Israel?
Your answer should be very brief. 1.31. What is the ratio of the Imports(as % of merchandise exports) of 1962 in Greece to that in Italy?
Ensure brevity in your answer.  0.55. What is the ratio of the Imports(as % of merchandise exports) in 1963 in Greece to that in Italy?
Make the answer very short. 0.71. What is the ratio of the Imports(as % of merchandise exports) in 1964 in Greece to that in Italy?
Offer a terse response. 0.49. What is the ratio of the Imports(as % of merchandise exports) of 1965 in Greece to that in Italy?
Your answer should be very brief. 0.54. What is the ratio of the Imports(as % of merchandise exports) of 1962 in Hong Kong to that in Iceland?
Make the answer very short. 0.28. What is the ratio of the Imports(as % of merchandise exports) in 1963 in Hong Kong to that in Iceland?
Offer a very short reply. 0.31. What is the ratio of the Imports(as % of merchandise exports) of 1964 in Hong Kong to that in Iceland?
Provide a succinct answer. 0.33. What is the ratio of the Imports(as % of merchandise exports) in 1965 in Hong Kong to that in Iceland?
Your answer should be very brief. 0.36. What is the ratio of the Imports(as % of merchandise exports) in 1962 in Hong Kong to that in Israel?
Your answer should be compact. 0.56. What is the ratio of the Imports(as % of merchandise exports) in 1963 in Hong Kong to that in Israel?
Ensure brevity in your answer.  0.52. What is the ratio of the Imports(as % of merchandise exports) of 1964 in Hong Kong to that in Israel?
Keep it short and to the point. 0.53. What is the ratio of the Imports(as % of merchandise exports) in 1965 in Hong Kong to that in Israel?
Your answer should be very brief. 0.5. What is the ratio of the Imports(as % of merchandise exports) in 1962 in Hong Kong to that in Italy?
Provide a short and direct response. 0.27. What is the ratio of the Imports(as % of merchandise exports) in 1963 in Hong Kong to that in Italy?
Keep it short and to the point. 0.29. What is the ratio of the Imports(as % of merchandise exports) of 1964 in Hong Kong to that in Italy?
Your response must be concise. 0.22. What is the ratio of the Imports(as % of merchandise exports) in 1965 in Hong Kong to that in Italy?
Ensure brevity in your answer.  0.21. What is the ratio of the Imports(as % of merchandise exports) of 1962 in Iceland to that in Israel?
Provide a succinct answer. 1.97. What is the ratio of the Imports(as % of merchandise exports) in 1963 in Iceland to that in Israel?
Offer a terse response. 1.68. What is the ratio of the Imports(as % of merchandise exports) in 1964 in Iceland to that in Israel?
Ensure brevity in your answer.  1.63. What is the ratio of the Imports(as % of merchandise exports) in 1965 in Iceland to that in Israel?
Your answer should be compact. 1.41. What is the ratio of the Imports(as % of merchandise exports) in 1962 in Iceland to that in Italy?
Provide a short and direct response. 0.95. What is the ratio of the Imports(as % of merchandise exports) in 1963 in Iceland to that in Italy?
Your answer should be very brief. 0.93. What is the ratio of the Imports(as % of merchandise exports) of 1964 in Iceland to that in Italy?
Your answer should be compact. 0.66. What is the ratio of the Imports(as % of merchandise exports) of 1965 in Iceland to that in Italy?
Offer a terse response. 0.58. What is the ratio of the Imports(as % of merchandise exports) in 1962 in Israel to that in Italy?
Give a very brief answer. 0.48. What is the ratio of the Imports(as % of merchandise exports) in 1963 in Israel to that in Italy?
Your answer should be compact. 0.55. What is the ratio of the Imports(as % of merchandise exports) of 1964 in Israel to that in Italy?
Your answer should be compact. 0.41. What is the ratio of the Imports(as % of merchandise exports) of 1965 in Israel to that in Italy?
Your answer should be very brief. 0.41. What is the difference between the highest and the second highest Imports(as % of merchandise exports) of 1962?
Give a very brief answer. 0.62. What is the difference between the highest and the second highest Imports(as % of merchandise exports) in 1963?
Keep it short and to the point. 1.24. What is the difference between the highest and the second highest Imports(as % of merchandise exports) of 1964?
Your answer should be very brief. 1.05. What is the difference between the highest and the second highest Imports(as % of merchandise exports) in 1965?
Provide a short and direct response. 2.61. What is the difference between the highest and the lowest Imports(as % of merchandise exports) of 1962?
Ensure brevity in your answer.  9.76. What is the difference between the highest and the lowest Imports(as % of merchandise exports) in 1963?
Give a very brief answer. 9.94. What is the difference between the highest and the lowest Imports(as % of merchandise exports) of 1964?
Offer a very short reply. 12.06. What is the difference between the highest and the lowest Imports(as % of merchandise exports) in 1965?
Ensure brevity in your answer.  12.48. 